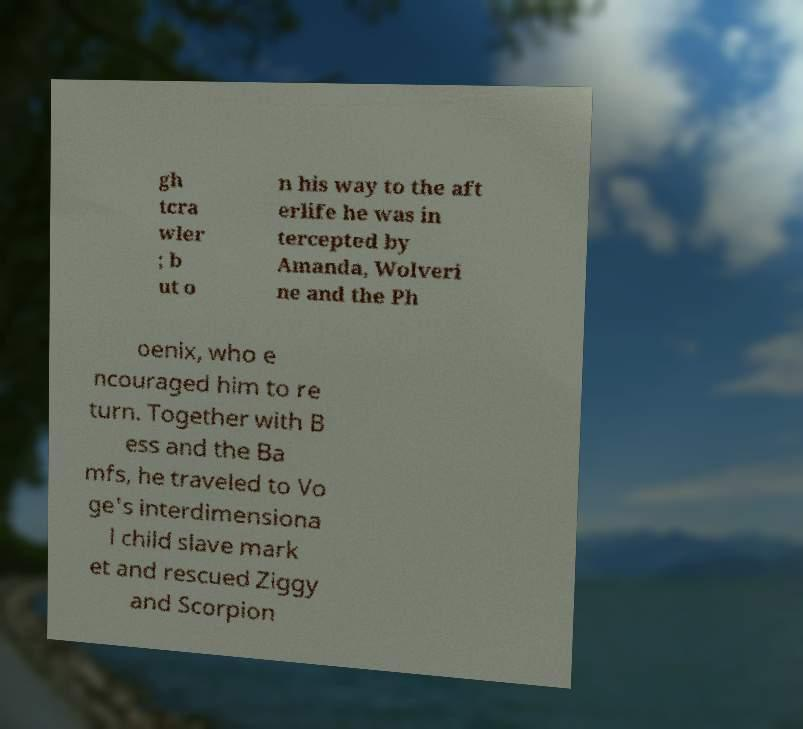There's text embedded in this image that I need extracted. Can you transcribe it verbatim? gh tcra wler ; b ut o n his way to the aft erlife he was in tercepted by Amanda, Wolveri ne and the Ph oenix, who e ncouraged him to re turn. Together with B ess and the Ba mfs, he traveled to Vo ge's interdimensiona l child slave mark et and rescued Ziggy and Scorpion 